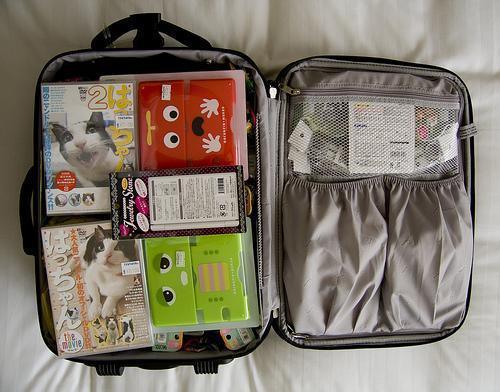How many magazines are there?
Give a very brief answer. 2. 